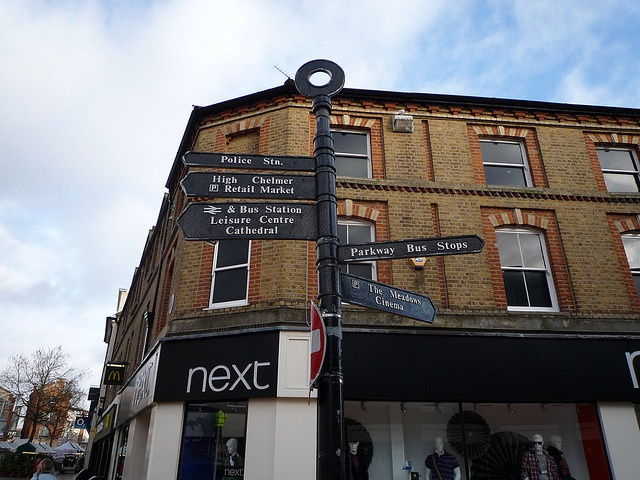Describe the objects in this image and their specific colors. I can see people in lavender, black, and gray tones and people in maroon, black, gray, and lavender tones in this image. 